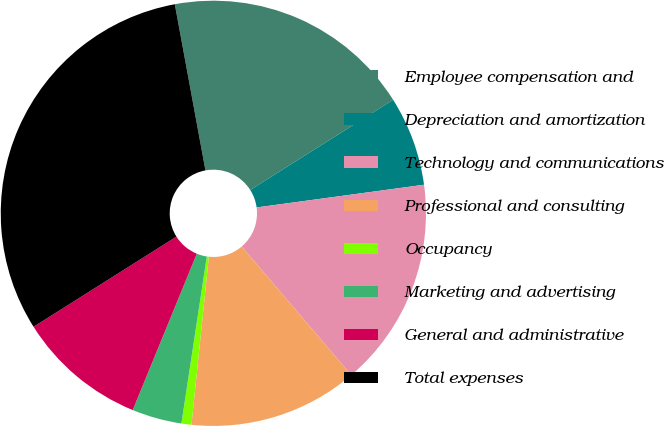Convert chart. <chart><loc_0><loc_0><loc_500><loc_500><pie_chart><fcel>Employee compensation and<fcel>Depreciation and amortization<fcel>Technology and communications<fcel>Professional and consulting<fcel>Occupancy<fcel>Marketing and advertising<fcel>General and administrative<fcel>Total expenses<nl><fcel>18.94%<fcel>6.82%<fcel>15.91%<fcel>12.88%<fcel>0.76%<fcel>3.79%<fcel>9.85%<fcel>31.06%<nl></chart> 